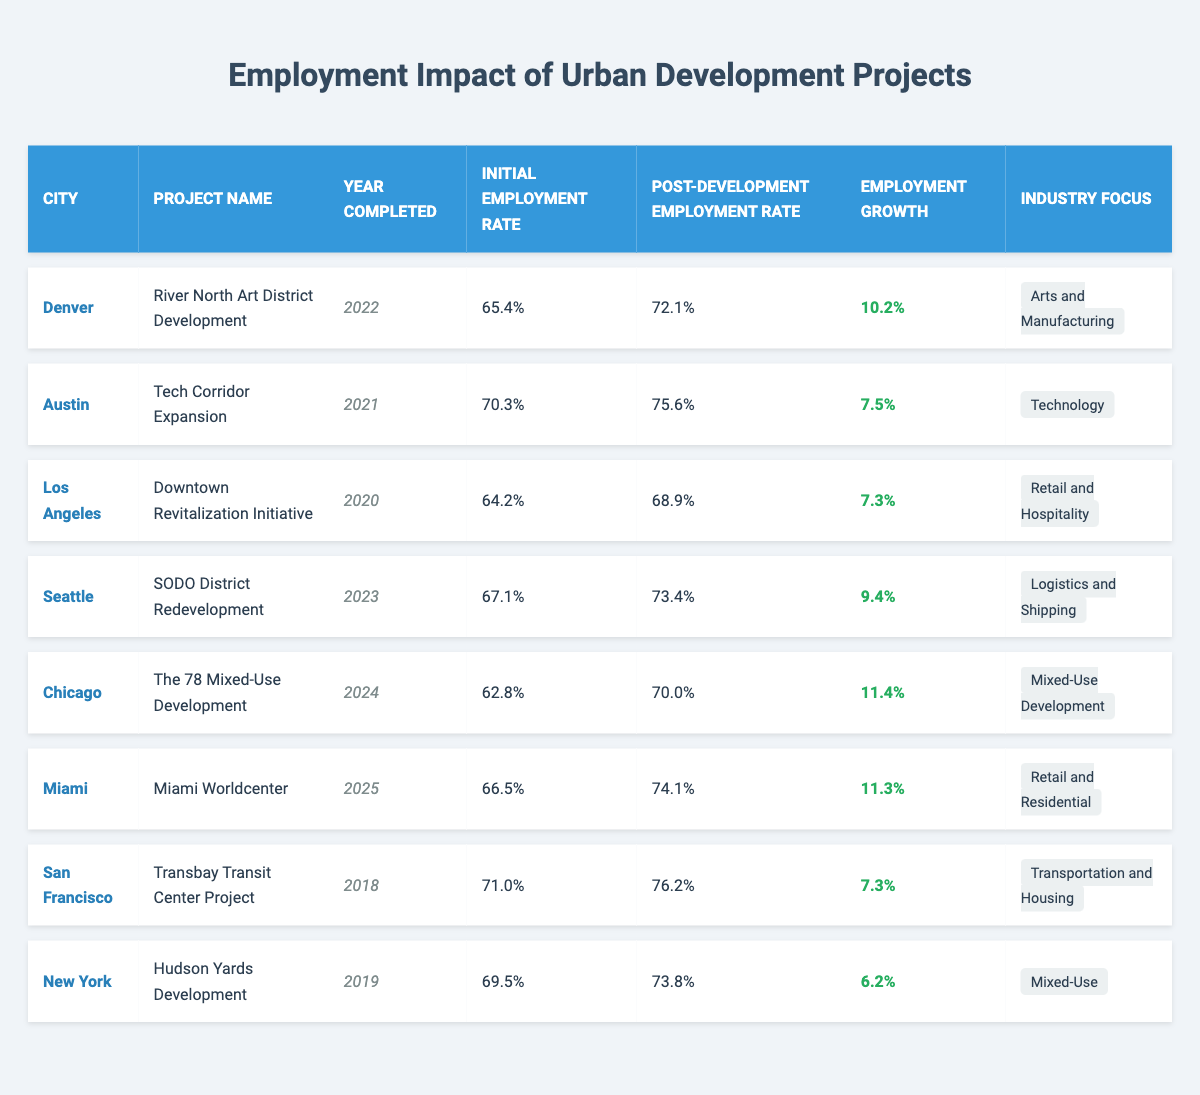What is the employment growth percentage in Denver? In the row for Denver, the employment growth percentage is explicitly listed as 10.2%
Answer: 10.2% Which project had the highest post-development employment rate? Examining the post-development employment rates, Miami Worldcenter has the highest rate at 74.1%
Answer: 74.1% What is the average initial employment rate across all projects? To find the average, we sum the initial employment rates: 65.4 + 70.3 + 64.2 + 67.1 + 62.8 + 66.5 + 71.0 + 69.5 =  67.5, and divide by the number of projects (8) giving us an average of 67.5%
Answer: 67.5% Was the post-development employment rate in Seattle higher than the initial employment rate in Austin? Seattle's post-development rate is 73.4% and Austin's initial rate is 70.3%. Since 73.4% is greater than 70.3%, the statement is true
Answer: Yes Which city experienced the least employment growth? By comparing all employment growth percentages, New York recorded the lowest growth at 6.2%
Answer: 6.2% Is the industry focus of the Miami Worldcenter project in the retail sector? The industry focus for Miami Worldcenter is listed as "Retail and Residential," indicating it is indeed in the retail sector, making this statement true
Answer: Yes What is the difference between the post-development employment rate of Chicago and that of Austin? The post-development rate for Chicago is 70.0% and for Austin, it's 75.6%. The difference is 75.6% - 70.0% = 5.6%
Answer: 5.6% Which city projects had an employment growth rate of over 10%? Denver (10.2%), Chicago (11.4%), and Miami (11.3%) all had growth rates exceeding 10%
Answer: Denver, Chicago, Miami What is the median initial employment rate from the given data? The initial rates are: 65.4, 70.3, 64.2, 67.1, 62.8, 66.5, 71.0, and 69.5. When ordered: 62.8, 64.2, 65.4, 66.5, 67.1, 69.5, 70.3, 71.0. With 8 data points, the median is the average of the 4th and 5th data points: (66.5 + 67.1)/2 = 66.8%
Answer: 66.8% In which year was the Transbay Transit Center Project completed? The year of completion is given in the table, and the Transbay Transit Center Project was completed in 2018
Answer: 2018 How many projects were completed before 2021? Looking at the years of completion, the projects completed before 2021 are in 2018 (1), 2019 (1), and 2020 (1), totaling 3 projects
Answer: 3 